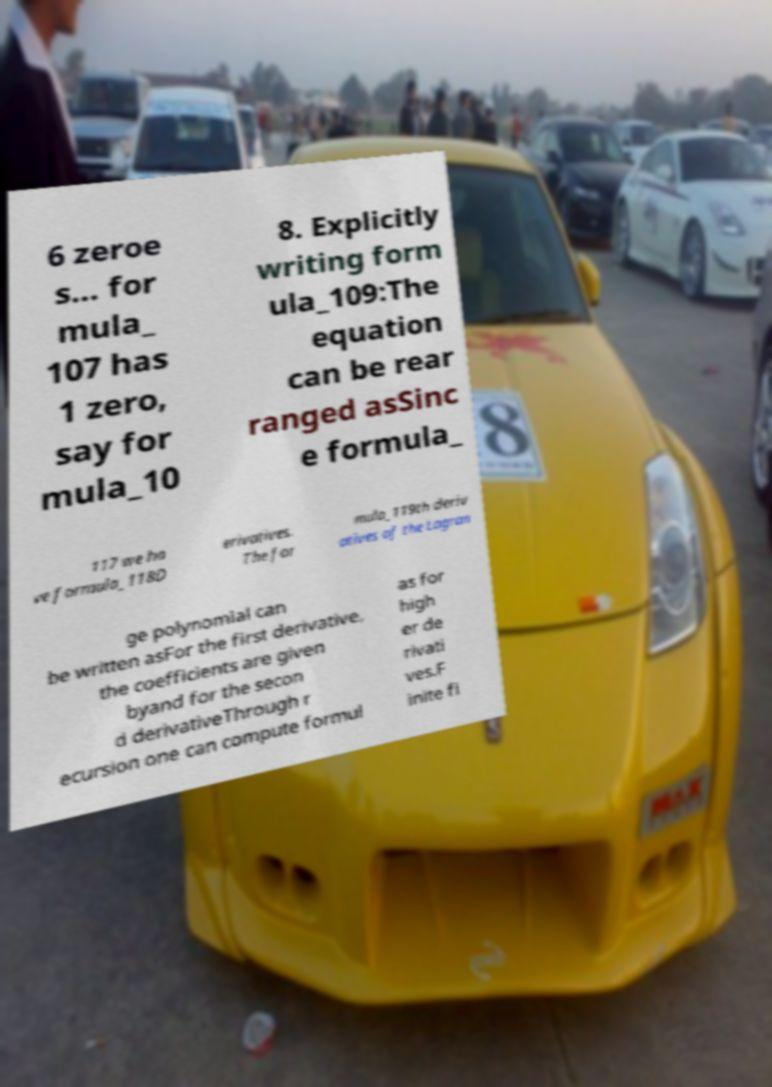For documentation purposes, I need the text within this image transcribed. Could you provide that? 6 zeroe s... for mula_ 107 has 1 zero, say for mula_10 8. Explicitly writing form ula_109:The equation can be rear ranged asSinc e formula_ 117 we ha ve formula_118D erivatives. The for mula_119th deriv atives of the Lagran ge polynomial can be written asFor the first derivative, the coefficients are given byand for the secon d derivativeThrough r ecursion one can compute formul as for high er de rivati ves.F inite fi 